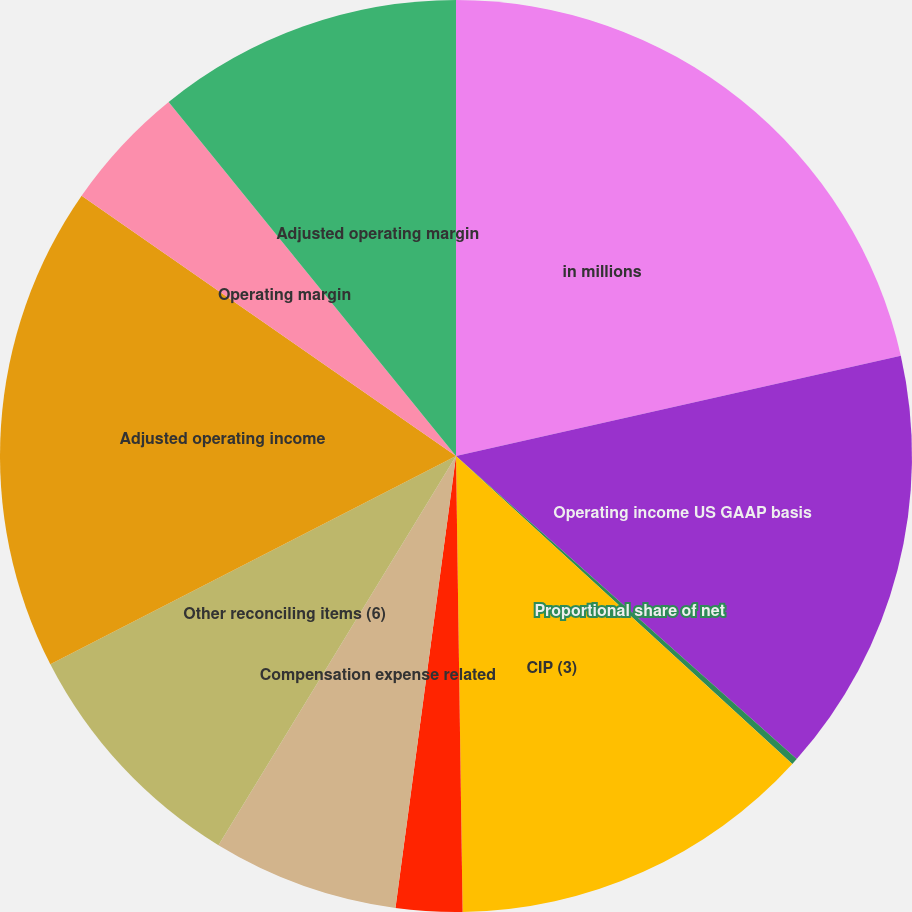<chart> <loc_0><loc_0><loc_500><loc_500><pie_chart><fcel>in millions<fcel>Operating income US GAAP basis<fcel>Proportional share of net<fcel>CIP (3)<fcel>Acquisition/disposition<fcel>Compensation expense related<fcel>Other reconciling items (6)<fcel>Adjusted operating income<fcel>Operating margin<fcel>Adjusted operating margin<nl><fcel>21.47%<fcel>15.1%<fcel>0.23%<fcel>12.97%<fcel>2.35%<fcel>6.6%<fcel>8.73%<fcel>17.22%<fcel>4.48%<fcel>10.85%<nl></chart> 